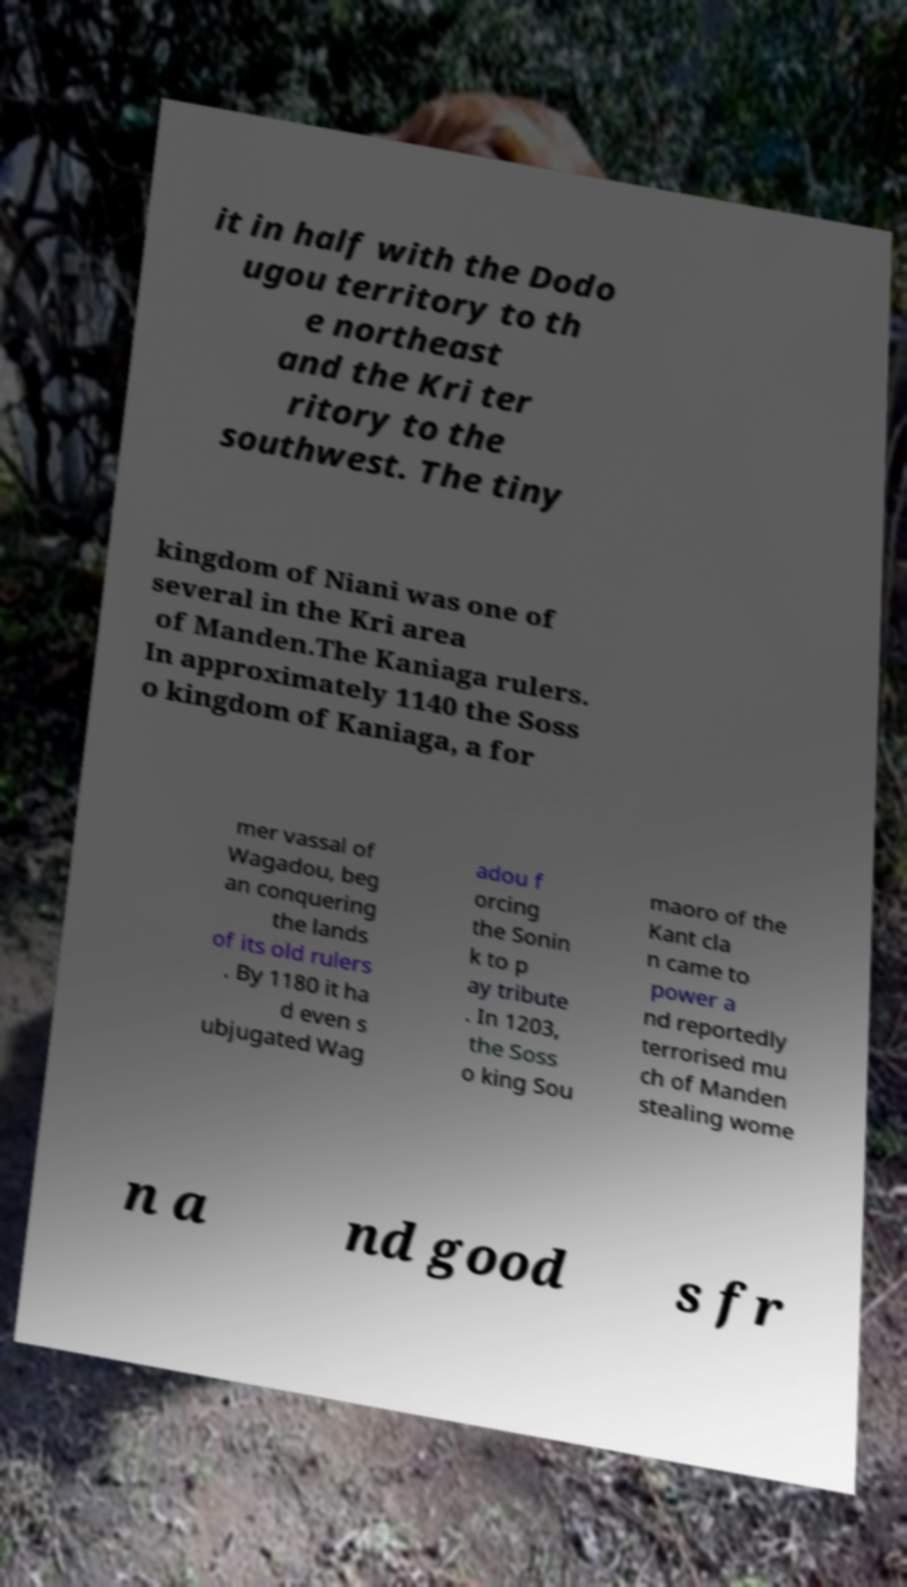Please read and relay the text visible in this image. What does it say? it in half with the Dodo ugou territory to th e northeast and the Kri ter ritory to the southwest. The tiny kingdom of Niani was one of several in the Kri area of Manden.The Kaniaga rulers. In approximately 1140 the Soss o kingdom of Kaniaga, a for mer vassal of Wagadou, beg an conquering the lands of its old rulers . By 1180 it ha d even s ubjugated Wag adou f orcing the Sonin k to p ay tribute . In 1203, the Soss o king Sou maoro of the Kant cla n came to power a nd reportedly terrorised mu ch of Manden stealing wome n a nd good s fr 